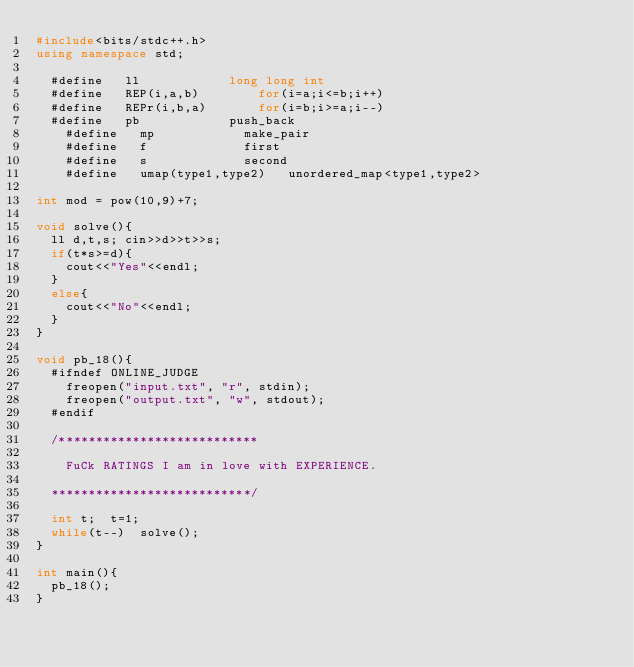<code> <loc_0><loc_0><loc_500><loc_500><_C++_>#include<bits/stdc++.h>
using namespace std;
	
	#define 	ll 						long long int
	#define 	REP(i,a,b)				for(i=a;i<=b;i++)
	#define 	REPr(i,b,a)				for(i=b;i>=a;i--)
	#define 	pb 						push_back
    #define 	mp 						make_pair
    #define 	f  						first
   	#define 	s  						second
   	#define 	umap(type1,type2)		unordered_map<type1,type2>

int mod = pow(10,9)+7;

void solve(){
	ll d,t,s;	cin>>d>>t>>s;
	if(t*s>=d){
		cout<<"Yes"<<endl;
	}
	else{
		cout<<"No"<<endl;
	}
}

void pb_18(){
	#ifndef ONLINE_JUDGE
    freopen("input.txt", "r", stdin);
    freopen("output.txt", "w", stdout);
	#endif

	/***************************

		FuCk RATINGS I am in love with EXPERIENCE.

	***************************/

	int t;	t=1;
	while(t--)	solve();
}

int main(){
	pb_18();
}</code> 